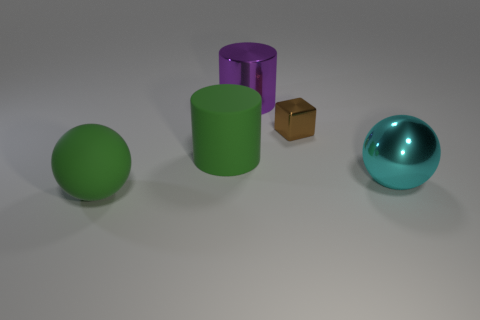Add 4 rubber spheres. How many objects exist? 9 Subtract all cylinders. How many objects are left? 3 Subtract all big things. Subtract all green cylinders. How many objects are left? 0 Add 2 big purple objects. How many big purple objects are left? 3 Add 3 large blue rubber balls. How many large blue rubber balls exist? 3 Subtract 0 red spheres. How many objects are left? 5 